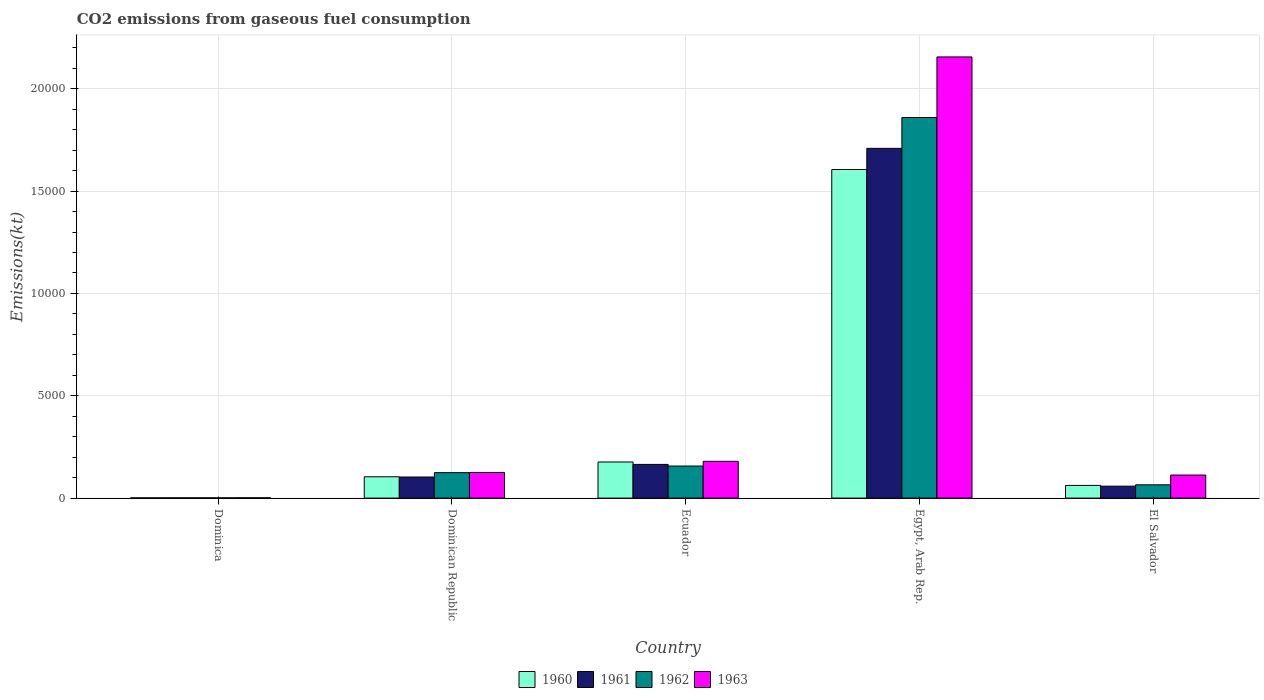How many different coloured bars are there?
Provide a succinct answer. 4. Are the number of bars on each tick of the X-axis equal?
Provide a short and direct response. Yes. How many bars are there on the 2nd tick from the left?
Your answer should be compact. 4. How many bars are there on the 3rd tick from the right?
Provide a succinct answer. 4. What is the label of the 1st group of bars from the left?
Give a very brief answer. Dominica. In how many cases, is the number of bars for a given country not equal to the number of legend labels?
Offer a very short reply. 0. What is the amount of CO2 emitted in 1963 in El Salvador?
Your response must be concise. 1125.77. Across all countries, what is the maximum amount of CO2 emitted in 1961?
Give a very brief answer. 1.71e+04. Across all countries, what is the minimum amount of CO2 emitted in 1960?
Give a very brief answer. 11. In which country was the amount of CO2 emitted in 1960 maximum?
Offer a terse response. Egypt, Arab Rep. In which country was the amount of CO2 emitted in 1960 minimum?
Make the answer very short. Dominica. What is the total amount of CO2 emitted in 1961 in the graph?
Your response must be concise. 2.04e+04. What is the difference between the amount of CO2 emitted in 1963 in Dominican Republic and that in Ecuador?
Make the answer very short. -546.38. What is the difference between the amount of CO2 emitted in 1961 in El Salvador and the amount of CO2 emitted in 1962 in Egypt, Arab Rep.?
Keep it short and to the point. -1.80e+04. What is the average amount of CO2 emitted in 1960 per country?
Your answer should be compact. 3898.02. What is the difference between the amount of CO2 emitted of/in 1961 and amount of CO2 emitted of/in 1963 in Egypt, Arab Rep.?
Your response must be concise. -4466.41. What is the ratio of the amount of CO2 emitted in 1962 in Ecuador to that in El Salvador?
Give a very brief answer. 2.41. Is the difference between the amount of CO2 emitted in 1961 in Ecuador and Egypt, Arab Rep. greater than the difference between the amount of CO2 emitted in 1963 in Ecuador and Egypt, Arab Rep.?
Provide a succinct answer. Yes. What is the difference between the highest and the second highest amount of CO2 emitted in 1963?
Your response must be concise. 1.98e+04. What is the difference between the highest and the lowest amount of CO2 emitted in 1962?
Make the answer very short. 1.86e+04. Is the sum of the amount of CO2 emitted in 1963 in Dominica and Egypt, Arab Rep. greater than the maximum amount of CO2 emitted in 1961 across all countries?
Your response must be concise. Yes. What does the 2nd bar from the left in El Salvador represents?
Keep it short and to the point. 1961. Is it the case that in every country, the sum of the amount of CO2 emitted in 1961 and amount of CO2 emitted in 1962 is greater than the amount of CO2 emitted in 1963?
Your answer should be compact. Yes. How many bars are there?
Your response must be concise. 20. Are all the bars in the graph horizontal?
Provide a short and direct response. No. What is the difference between two consecutive major ticks on the Y-axis?
Your response must be concise. 5000. Are the values on the major ticks of Y-axis written in scientific E-notation?
Give a very brief answer. No. Does the graph contain any zero values?
Provide a succinct answer. No. Does the graph contain grids?
Your answer should be very brief. Yes. How are the legend labels stacked?
Keep it short and to the point. Horizontal. What is the title of the graph?
Provide a short and direct response. CO2 emissions from gaseous fuel consumption. Does "1996" appear as one of the legend labels in the graph?
Your response must be concise. No. What is the label or title of the X-axis?
Keep it short and to the point. Country. What is the label or title of the Y-axis?
Your response must be concise. Emissions(kt). What is the Emissions(kt) in 1960 in Dominica?
Make the answer very short. 11. What is the Emissions(kt) in 1961 in Dominica?
Ensure brevity in your answer.  11. What is the Emissions(kt) of 1962 in Dominica?
Provide a succinct answer. 11. What is the Emissions(kt) in 1963 in Dominica?
Make the answer very short. 14.67. What is the Emissions(kt) of 1960 in Dominican Republic?
Give a very brief answer. 1041.43. What is the Emissions(kt) in 1961 in Dominican Republic?
Give a very brief answer. 1030.43. What is the Emissions(kt) of 1962 in Dominican Republic?
Give a very brief answer. 1243.11. What is the Emissions(kt) in 1963 in Dominican Republic?
Make the answer very short. 1250.45. What is the Emissions(kt) of 1960 in Ecuador?
Your answer should be compact. 1763.83. What is the Emissions(kt) of 1961 in Ecuador?
Provide a succinct answer. 1646.48. What is the Emissions(kt) in 1962 in Ecuador?
Give a very brief answer. 1565.81. What is the Emissions(kt) of 1963 in Ecuador?
Ensure brevity in your answer.  1796.83. What is the Emissions(kt) of 1960 in Egypt, Arab Rep.?
Provide a succinct answer. 1.61e+04. What is the Emissions(kt) in 1961 in Egypt, Arab Rep.?
Keep it short and to the point. 1.71e+04. What is the Emissions(kt) of 1962 in Egypt, Arab Rep.?
Offer a terse response. 1.86e+04. What is the Emissions(kt) of 1963 in Egypt, Arab Rep.?
Your response must be concise. 2.16e+04. What is the Emissions(kt) of 1960 in El Salvador?
Your answer should be very brief. 619.72. What is the Emissions(kt) in 1961 in El Salvador?
Make the answer very short. 583.05. What is the Emissions(kt) of 1962 in El Salvador?
Give a very brief answer. 649.06. What is the Emissions(kt) in 1963 in El Salvador?
Ensure brevity in your answer.  1125.77. Across all countries, what is the maximum Emissions(kt) in 1960?
Keep it short and to the point. 1.61e+04. Across all countries, what is the maximum Emissions(kt) in 1961?
Keep it short and to the point. 1.71e+04. Across all countries, what is the maximum Emissions(kt) in 1962?
Ensure brevity in your answer.  1.86e+04. Across all countries, what is the maximum Emissions(kt) in 1963?
Provide a succinct answer. 2.16e+04. Across all countries, what is the minimum Emissions(kt) of 1960?
Provide a short and direct response. 11. Across all countries, what is the minimum Emissions(kt) of 1961?
Provide a succinct answer. 11. Across all countries, what is the minimum Emissions(kt) in 1962?
Offer a terse response. 11. Across all countries, what is the minimum Emissions(kt) of 1963?
Ensure brevity in your answer.  14.67. What is the total Emissions(kt) of 1960 in the graph?
Offer a terse response. 1.95e+04. What is the total Emissions(kt) in 1961 in the graph?
Your answer should be compact. 2.04e+04. What is the total Emissions(kt) in 1962 in the graph?
Your response must be concise. 2.21e+04. What is the total Emissions(kt) of 1963 in the graph?
Keep it short and to the point. 2.57e+04. What is the difference between the Emissions(kt) of 1960 in Dominica and that in Dominican Republic?
Your answer should be compact. -1030.43. What is the difference between the Emissions(kt) in 1961 in Dominica and that in Dominican Republic?
Offer a terse response. -1019.43. What is the difference between the Emissions(kt) in 1962 in Dominica and that in Dominican Republic?
Provide a short and direct response. -1232.11. What is the difference between the Emissions(kt) in 1963 in Dominica and that in Dominican Republic?
Offer a very short reply. -1235.78. What is the difference between the Emissions(kt) in 1960 in Dominica and that in Ecuador?
Make the answer very short. -1752.83. What is the difference between the Emissions(kt) of 1961 in Dominica and that in Ecuador?
Make the answer very short. -1635.48. What is the difference between the Emissions(kt) in 1962 in Dominica and that in Ecuador?
Offer a terse response. -1554.81. What is the difference between the Emissions(kt) of 1963 in Dominica and that in Ecuador?
Your answer should be compact. -1782.16. What is the difference between the Emissions(kt) of 1960 in Dominica and that in Egypt, Arab Rep.?
Give a very brief answer. -1.60e+04. What is the difference between the Emissions(kt) in 1961 in Dominica and that in Egypt, Arab Rep.?
Provide a succinct answer. -1.71e+04. What is the difference between the Emissions(kt) in 1962 in Dominica and that in Egypt, Arab Rep.?
Your response must be concise. -1.86e+04. What is the difference between the Emissions(kt) of 1963 in Dominica and that in Egypt, Arab Rep.?
Your answer should be compact. -2.15e+04. What is the difference between the Emissions(kt) of 1960 in Dominica and that in El Salvador?
Your answer should be compact. -608.72. What is the difference between the Emissions(kt) in 1961 in Dominica and that in El Salvador?
Your response must be concise. -572.05. What is the difference between the Emissions(kt) in 1962 in Dominica and that in El Salvador?
Keep it short and to the point. -638.06. What is the difference between the Emissions(kt) of 1963 in Dominica and that in El Salvador?
Your answer should be very brief. -1111.1. What is the difference between the Emissions(kt) of 1960 in Dominican Republic and that in Ecuador?
Your answer should be compact. -722.4. What is the difference between the Emissions(kt) in 1961 in Dominican Republic and that in Ecuador?
Give a very brief answer. -616.06. What is the difference between the Emissions(kt) in 1962 in Dominican Republic and that in Ecuador?
Provide a short and direct response. -322.7. What is the difference between the Emissions(kt) of 1963 in Dominican Republic and that in Ecuador?
Offer a terse response. -546.38. What is the difference between the Emissions(kt) in 1960 in Dominican Republic and that in Egypt, Arab Rep.?
Keep it short and to the point. -1.50e+04. What is the difference between the Emissions(kt) in 1961 in Dominican Republic and that in Egypt, Arab Rep.?
Provide a short and direct response. -1.61e+04. What is the difference between the Emissions(kt) of 1962 in Dominican Republic and that in Egypt, Arab Rep.?
Keep it short and to the point. -1.74e+04. What is the difference between the Emissions(kt) of 1963 in Dominican Republic and that in Egypt, Arab Rep.?
Offer a terse response. -2.03e+04. What is the difference between the Emissions(kt) of 1960 in Dominican Republic and that in El Salvador?
Your answer should be very brief. 421.7. What is the difference between the Emissions(kt) of 1961 in Dominican Republic and that in El Salvador?
Offer a terse response. 447.37. What is the difference between the Emissions(kt) in 1962 in Dominican Republic and that in El Salvador?
Offer a very short reply. 594.05. What is the difference between the Emissions(kt) of 1963 in Dominican Republic and that in El Salvador?
Your response must be concise. 124.68. What is the difference between the Emissions(kt) in 1960 in Ecuador and that in Egypt, Arab Rep.?
Your answer should be compact. -1.43e+04. What is the difference between the Emissions(kt) of 1961 in Ecuador and that in Egypt, Arab Rep.?
Make the answer very short. -1.54e+04. What is the difference between the Emissions(kt) of 1962 in Ecuador and that in Egypt, Arab Rep.?
Offer a very short reply. -1.70e+04. What is the difference between the Emissions(kt) of 1963 in Ecuador and that in Egypt, Arab Rep.?
Your answer should be very brief. -1.98e+04. What is the difference between the Emissions(kt) in 1960 in Ecuador and that in El Salvador?
Make the answer very short. 1144.1. What is the difference between the Emissions(kt) of 1961 in Ecuador and that in El Salvador?
Provide a short and direct response. 1063.43. What is the difference between the Emissions(kt) of 1962 in Ecuador and that in El Salvador?
Provide a short and direct response. 916.75. What is the difference between the Emissions(kt) of 1963 in Ecuador and that in El Salvador?
Make the answer very short. 671.06. What is the difference between the Emissions(kt) of 1960 in Egypt, Arab Rep. and that in El Salvador?
Your answer should be very brief. 1.54e+04. What is the difference between the Emissions(kt) in 1961 in Egypt, Arab Rep. and that in El Salvador?
Your answer should be compact. 1.65e+04. What is the difference between the Emissions(kt) in 1962 in Egypt, Arab Rep. and that in El Salvador?
Offer a very short reply. 1.79e+04. What is the difference between the Emissions(kt) in 1963 in Egypt, Arab Rep. and that in El Salvador?
Offer a very short reply. 2.04e+04. What is the difference between the Emissions(kt) in 1960 in Dominica and the Emissions(kt) in 1961 in Dominican Republic?
Ensure brevity in your answer.  -1019.43. What is the difference between the Emissions(kt) of 1960 in Dominica and the Emissions(kt) of 1962 in Dominican Republic?
Provide a succinct answer. -1232.11. What is the difference between the Emissions(kt) in 1960 in Dominica and the Emissions(kt) in 1963 in Dominican Republic?
Make the answer very short. -1239.45. What is the difference between the Emissions(kt) of 1961 in Dominica and the Emissions(kt) of 1962 in Dominican Republic?
Ensure brevity in your answer.  -1232.11. What is the difference between the Emissions(kt) of 1961 in Dominica and the Emissions(kt) of 1963 in Dominican Republic?
Your response must be concise. -1239.45. What is the difference between the Emissions(kt) in 1962 in Dominica and the Emissions(kt) in 1963 in Dominican Republic?
Provide a short and direct response. -1239.45. What is the difference between the Emissions(kt) in 1960 in Dominica and the Emissions(kt) in 1961 in Ecuador?
Your answer should be compact. -1635.48. What is the difference between the Emissions(kt) of 1960 in Dominica and the Emissions(kt) of 1962 in Ecuador?
Your answer should be very brief. -1554.81. What is the difference between the Emissions(kt) in 1960 in Dominica and the Emissions(kt) in 1963 in Ecuador?
Make the answer very short. -1785.83. What is the difference between the Emissions(kt) in 1961 in Dominica and the Emissions(kt) in 1962 in Ecuador?
Provide a succinct answer. -1554.81. What is the difference between the Emissions(kt) in 1961 in Dominica and the Emissions(kt) in 1963 in Ecuador?
Offer a terse response. -1785.83. What is the difference between the Emissions(kt) in 1962 in Dominica and the Emissions(kt) in 1963 in Ecuador?
Your answer should be compact. -1785.83. What is the difference between the Emissions(kt) in 1960 in Dominica and the Emissions(kt) in 1961 in Egypt, Arab Rep.?
Offer a terse response. -1.71e+04. What is the difference between the Emissions(kt) in 1960 in Dominica and the Emissions(kt) in 1962 in Egypt, Arab Rep.?
Your answer should be very brief. -1.86e+04. What is the difference between the Emissions(kt) of 1960 in Dominica and the Emissions(kt) of 1963 in Egypt, Arab Rep.?
Offer a very short reply. -2.15e+04. What is the difference between the Emissions(kt) of 1961 in Dominica and the Emissions(kt) of 1962 in Egypt, Arab Rep.?
Give a very brief answer. -1.86e+04. What is the difference between the Emissions(kt) of 1961 in Dominica and the Emissions(kt) of 1963 in Egypt, Arab Rep.?
Your answer should be compact. -2.15e+04. What is the difference between the Emissions(kt) in 1962 in Dominica and the Emissions(kt) in 1963 in Egypt, Arab Rep.?
Give a very brief answer. -2.15e+04. What is the difference between the Emissions(kt) in 1960 in Dominica and the Emissions(kt) in 1961 in El Salvador?
Your response must be concise. -572.05. What is the difference between the Emissions(kt) in 1960 in Dominica and the Emissions(kt) in 1962 in El Salvador?
Your answer should be compact. -638.06. What is the difference between the Emissions(kt) of 1960 in Dominica and the Emissions(kt) of 1963 in El Salvador?
Give a very brief answer. -1114.77. What is the difference between the Emissions(kt) in 1961 in Dominica and the Emissions(kt) in 1962 in El Salvador?
Keep it short and to the point. -638.06. What is the difference between the Emissions(kt) in 1961 in Dominica and the Emissions(kt) in 1963 in El Salvador?
Your answer should be very brief. -1114.77. What is the difference between the Emissions(kt) of 1962 in Dominica and the Emissions(kt) of 1963 in El Salvador?
Give a very brief answer. -1114.77. What is the difference between the Emissions(kt) of 1960 in Dominican Republic and the Emissions(kt) of 1961 in Ecuador?
Give a very brief answer. -605.05. What is the difference between the Emissions(kt) in 1960 in Dominican Republic and the Emissions(kt) in 1962 in Ecuador?
Your response must be concise. -524.38. What is the difference between the Emissions(kt) of 1960 in Dominican Republic and the Emissions(kt) of 1963 in Ecuador?
Make the answer very short. -755.4. What is the difference between the Emissions(kt) of 1961 in Dominican Republic and the Emissions(kt) of 1962 in Ecuador?
Give a very brief answer. -535.38. What is the difference between the Emissions(kt) of 1961 in Dominican Republic and the Emissions(kt) of 1963 in Ecuador?
Your answer should be very brief. -766.4. What is the difference between the Emissions(kt) in 1962 in Dominican Republic and the Emissions(kt) in 1963 in Ecuador?
Provide a short and direct response. -553.72. What is the difference between the Emissions(kt) of 1960 in Dominican Republic and the Emissions(kt) of 1961 in Egypt, Arab Rep.?
Provide a short and direct response. -1.60e+04. What is the difference between the Emissions(kt) in 1960 in Dominican Republic and the Emissions(kt) in 1962 in Egypt, Arab Rep.?
Give a very brief answer. -1.76e+04. What is the difference between the Emissions(kt) of 1960 in Dominican Republic and the Emissions(kt) of 1963 in Egypt, Arab Rep.?
Offer a terse response. -2.05e+04. What is the difference between the Emissions(kt) of 1961 in Dominican Republic and the Emissions(kt) of 1962 in Egypt, Arab Rep.?
Give a very brief answer. -1.76e+04. What is the difference between the Emissions(kt) in 1961 in Dominican Republic and the Emissions(kt) in 1963 in Egypt, Arab Rep.?
Make the answer very short. -2.05e+04. What is the difference between the Emissions(kt) of 1962 in Dominican Republic and the Emissions(kt) of 1963 in Egypt, Arab Rep.?
Provide a short and direct response. -2.03e+04. What is the difference between the Emissions(kt) of 1960 in Dominican Republic and the Emissions(kt) of 1961 in El Salvador?
Make the answer very short. 458.38. What is the difference between the Emissions(kt) of 1960 in Dominican Republic and the Emissions(kt) of 1962 in El Salvador?
Provide a succinct answer. 392.37. What is the difference between the Emissions(kt) in 1960 in Dominican Republic and the Emissions(kt) in 1963 in El Salvador?
Your response must be concise. -84.34. What is the difference between the Emissions(kt) of 1961 in Dominican Republic and the Emissions(kt) of 1962 in El Salvador?
Provide a short and direct response. 381.37. What is the difference between the Emissions(kt) of 1961 in Dominican Republic and the Emissions(kt) of 1963 in El Salvador?
Your answer should be compact. -95.34. What is the difference between the Emissions(kt) of 1962 in Dominican Republic and the Emissions(kt) of 1963 in El Salvador?
Keep it short and to the point. 117.34. What is the difference between the Emissions(kt) in 1960 in Ecuador and the Emissions(kt) in 1961 in Egypt, Arab Rep.?
Make the answer very short. -1.53e+04. What is the difference between the Emissions(kt) in 1960 in Ecuador and the Emissions(kt) in 1962 in Egypt, Arab Rep.?
Offer a very short reply. -1.68e+04. What is the difference between the Emissions(kt) in 1960 in Ecuador and the Emissions(kt) in 1963 in Egypt, Arab Rep.?
Offer a terse response. -1.98e+04. What is the difference between the Emissions(kt) of 1961 in Ecuador and the Emissions(kt) of 1962 in Egypt, Arab Rep.?
Provide a succinct answer. -1.69e+04. What is the difference between the Emissions(kt) in 1961 in Ecuador and the Emissions(kt) in 1963 in Egypt, Arab Rep.?
Keep it short and to the point. -1.99e+04. What is the difference between the Emissions(kt) of 1962 in Ecuador and the Emissions(kt) of 1963 in Egypt, Arab Rep.?
Your answer should be very brief. -2.00e+04. What is the difference between the Emissions(kt) in 1960 in Ecuador and the Emissions(kt) in 1961 in El Salvador?
Your response must be concise. 1180.77. What is the difference between the Emissions(kt) of 1960 in Ecuador and the Emissions(kt) of 1962 in El Salvador?
Your response must be concise. 1114.77. What is the difference between the Emissions(kt) in 1960 in Ecuador and the Emissions(kt) in 1963 in El Salvador?
Offer a terse response. 638.06. What is the difference between the Emissions(kt) in 1961 in Ecuador and the Emissions(kt) in 1962 in El Salvador?
Offer a very short reply. 997.42. What is the difference between the Emissions(kt) of 1961 in Ecuador and the Emissions(kt) of 1963 in El Salvador?
Provide a succinct answer. 520.71. What is the difference between the Emissions(kt) in 1962 in Ecuador and the Emissions(kt) in 1963 in El Salvador?
Offer a very short reply. 440.04. What is the difference between the Emissions(kt) in 1960 in Egypt, Arab Rep. and the Emissions(kt) in 1961 in El Salvador?
Provide a short and direct response. 1.55e+04. What is the difference between the Emissions(kt) in 1960 in Egypt, Arab Rep. and the Emissions(kt) in 1962 in El Salvador?
Provide a short and direct response. 1.54e+04. What is the difference between the Emissions(kt) in 1960 in Egypt, Arab Rep. and the Emissions(kt) in 1963 in El Salvador?
Provide a succinct answer. 1.49e+04. What is the difference between the Emissions(kt) in 1961 in Egypt, Arab Rep. and the Emissions(kt) in 1962 in El Salvador?
Ensure brevity in your answer.  1.64e+04. What is the difference between the Emissions(kt) of 1961 in Egypt, Arab Rep. and the Emissions(kt) of 1963 in El Salvador?
Make the answer very short. 1.60e+04. What is the difference between the Emissions(kt) of 1962 in Egypt, Arab Rep. and the Emissions(kt) of 1963 in El Salvador?
Keep it short and to the point. 1.75e+04. What is the average Emissions(kt) of 1960 per country?
Keep it short and to the point. 3898.02. What is the average Emissions(kt) of 1961 per country?
Give a very brief answer. 4071.84. What is the average Emissions(kt) of 1962 per country?
Offer a very short reply. 4412.87. What is the average Emissions(kt) in 1963 per country?
Ensure brevity in your answer.  5148.47. What is the difference between the Emissions(kt) in 1960 and Emissions(kt) in 1963 in Dominica?
Keep it short and to the point. -3.67. What is the difference between the Emissions(kt) of 1961 and Emissions(kt) of 1962 in Dominica?
Your response must be concise. 0. What is the difference between the Emissions(kt) of 1961 and Emissions(kt) of 1963 in Dominica?
Offer a very short reply. -3.67. What is the difference between the Emissions(kt) in 1962 and Emissions(kt) in 1963 in Dominica?
Your response must be concise. -3.67. What is the difference between the Emissions(kt) of 1960 and Emissions(kt) of 1961 in Dominican Republic?
Offer a very short reply. 11. What is the difference between the Emissions(kt) in 1960 and Emissions(kt) in 1962 in Dominican Republic?
Keep it short and to the point. -201.69. What is the difference between the Emissions(kt) in 1960 and Emissions(kt) in 1963 in Dominican Republic?
Provide a succinct answer. -209.02. What is the difference between the Emissions(kt) of 1961 and Emissions(kt) of 1962 in Dominican Republic?
Ensure brevity in your answer.  -212.69. What is the difference between the Emissions(kt) in 1961 and Emissions(kt) in 1963 in Dominican Republic?
Offer a very short reply. -220.02. What is the difference between the Emissions(kt) in 1962 and Emissions(kt) in 1963 in Dominican Republic?
Offer a terse response. -7.33. What is the difference between the Emissions(kt) in 1960 and Emissions(kt) in 1961 in Ecuador?
Make the answer very short. 117.34. What is the difference between the Emissions(kt) in 1960 and Emissions(kt) in 1962 in Ecuador?
Keep it short and to the point. 198.02. What is the difference between the Emissions(kt) in 1960 and Emissions(kt) in 1963 in Ecuador?
Make the answer very short. -33. What is the difference between the Emissions(kt) of 1961 and Emissions(kt) of 1962 in Ecuador?
Provide a short and direct response. 80.67. What is the difference between the Emissions(kt) in 1961 and Emissions(kt) in 1963 in Ecuador?
Make the answer very short. -150.35. What is the difference between the Emissions(kt) in 1962 and Emissions(kt) in 1963 in Ecuador?
Give a very brief answer. -231.02. What is the difference between the Emissions(kt) in 1960 and Emissions(kt) in 1961 in Egypt, Arab Rep.?
Provide a succinct answer. -1034.09. What is the difference between the Emissions(kt) in 1960 and Emissions(kt) in 1962 in Egypt, Arab Rep.?
Provide a short and direct response. -2541.23. What is the difference between the Emissions(kt) in 1960 and Emissions(kt) in 1963 in Egypt, Arab Rep.?
Your answer should be very brief. -5500.5. What is the difference between the Emissions(kt) of 1961 and Emissions(kt) of 1962 in Egypt, Arab Rep.?
Offer a terse response. -1507.14. What is the difference between the Emissions(kt) in 1961 and Emissions(kt) in 1963 in Egypt, Arab Rep.?
Your response must be concise. -4466.41. What is the difference between the Emissions(kt) of 1962 and Emissions(kt) of 1963 in Egypt, Arab Rep.?
Provide a short and direct response. -2959.27. What is the difference between the Emissions(kt) in 1960 and Emissions(kt) in 1961 in El Salvador?
Provide a succinct answer. 36.67. What is the difference between the Emissions(kt) of 1960 and Emissions(kt) of 1962 in El Salvador?
Offer a terse response. -29.34. What is the difference between the Emissions(kt) in 1960 and Emissions(kt) in 1963 in El Salvador?
Provide a succinct answer. -506.05. What is the difference between the Emissions(kt) of 1961 and Emissions(kt) of 1962 in El Salvador?
Offer a very short reply. -66.01. What is the difference between the Emissions(kt) in 1961 and Emissions(kt) in 1963 in El Salvador?
Give a very brief answer. -542.72. What is the difference between the Emissions(kt) in 1962 and Emissions(kt) in 1963 in El Salvador?
Make the answer very short. -476.71. What is the ratio of the Emissions(kt) of 1960 in Dominica to that in Dominican Republic?
Your response must be concise. 0.01. What is the ratio of the Emissions(kt) in 1961 in Dominica to that in Dominican Republic?
Offer a terse response. 0.01. What is the ratio of the Emissions(kt) in 1962 in Dominica to that in Dominican Republic?
Offer a terse response. 0.01. What is the ratio of the Emissions(kt) in 1963 in Dominica to that in Dominican Republic?
Provide a succinct answer. 0.01. What is the ratio of the Emissions(kt) in 1960 in Dominica to that in Ecuador?
Your answer should be compact. 0.01. What is the ratio of the Emissions(kt) of 1961 in Dominica to that in Ecuador?
Your answer should be compact. 0.01. What is the ratio of the Emissions(kt) of 1962 in Dominica to that in Ecuador?
Your answer should be compact. 0.01. What is the ratio of the Emissions(kt) in 1963 in Dominica to that in Ecuador?
Provide a succinct answer. 0.01. What is the ratio of the Emissions(kt) of 1960 in Dominica to that in Egypt, Arab Rep.?
Your answer should be very brief. 0. What is the ratio of the Emissions(kt) in 1961 in Dominica to that in Egypt, Arab Rep.?
Make the answer very short. 0. What is the ratio of the Emissions(kt) in 1962 in Dominica to that in Egypt, Arab Rep.?
Your response must be concise. 0. What is the ratio of the Emissions(kt) in 1963 in Dominica to that in Egypt, Arab Rep.?
Offer a terse response. 0. What is the ratio of the Emissions(kt) in 1960 in Dominica to that in El Salvador?
Ensure brevity in your answer.  0.02. What is the ratio of the Emissions(kt) in 1961 in Dominica to that in El Salvador?
Your answer should be compact. 0.02. What is the ratio of the Emissions(kt) in 1962 in Dominica to that in El Salvador?
Give a very brief answer. 0.02. What is the ratio of the Emissions(kt) of 1963 in Dominica to that in El Salvador?
Ensure brevity in your answer.  0.01. What is the ratio of the Emissions(kt) in 1960 in Dominican Republic to that in Ecuador?
Give a very brief answer. 0.59. What is the ratio of the Emissions(kt) in 1961 in Dominican Republic to that in Ecuador?
Keep it short and to the point. 0.63. What is the ratio of the Emissions(kt) of 1962 in Dominican Republic to that in Ecuador?
Ensure brevity in your answer.  0.79. What is the ratio of the Emissions(kt) of 1963 in Dominican Republic to that in Ecuador?
Make the answer very short. 0.7. What is the ratio of the Emissions(kt) of 1960 in Dominican Republic to that in Egypt, Arab Rep.?
Make the answer very short. 0.06. What is the ratio of the Emissions(kt) of 1961 in Dominican Republic to that in Egypt, Arab Rep.?
Your answer should be very brief. 0.06. What is the ratio of the Emissions(kt) of 1962 in Dominican Republic to that in Egypt, Arab Rep.?
Keep it short and to the point. 0.07. What is the ratio of the Emissions(kt) of 1963 in Dominican Republic to that in Egypt, Arab Rep.?
Offer a very short reply. 0.06. What is the ratio of the Emissions(kt) of 1960 in Dominican Republic to that in El Salvador?
Provide a short and direct response. 1.68. What is the ratio of the Emissions(kt) of 1961 in Dominican Republic to that in El Salvador?
Make the answer very short. 1.77. What is the ratio of the Emissions(kt) of 1962 in Dominican Republic to that in El Salvador?
Your answer should be very brief. 1.92. What is the ratio of the Emissions(kt) of 1963 in Dominican Republic to that in El Salvador?
Offer a very short reply. 1.11. What is the ratio of the Emissions(kt) of 1960 in Ecuador to that in Egypt, Arab Rep.?
Offer a very short reply. 0.11. What is the ratio of the Emissions(kt) in 1961 in Ecuador to that in Egypt, Arab Rep.?
Your response must be concise. 0.1. What is the ratio of the Emissions(kt) in 1962 in Ecuador to that in Egypt, Arab Rep.?
Your answer should be very brief. 0.08. What is the ratio of the Emissions(kt) of 1963 in Ecuador to that in Egypt, Arab Rep.?
Your answer should be very brief. 0.08. What is the ratio of the Emissions(kt) in 1960 in Ecuador to that in El Salvador?
Your answer should be very brief. 2.85. What is the ratio of the Emissions(kt) in 1961 in Ecuador to that in El Salvador?
Your answer should be very brief. 2.82. What is the ratio of the Emissions(kt) of 1962 in Ecuador to that in El Salvador?
Your response must be concise. 2.41. What is the ratio of the Emissions(kt) in 1963 in Ecuador to that in El Salvador?
Your answer should be compact. 1.6. What is the ratio of the Emissions(kt) in 1960 in Egypt, Arab Rep. to that in El Salvador?
Your answer should be very brief. 25.91. What is the ratio of the Emissions(kt) in 1961 in Egypt, Arab Rep. to that in El Salvador?
Keep it short and to the point. 29.31. What is the ratio of the Emissions(kt) in 1962 in Egypt, Arab Rep. to that in El Salvador?
Offer a very short reply. 28.65. What is the ratio of the Emissions(kt) in 1963 in Egypt, Arab Rep. to that in El Salvador?
Your response must be concise. 19.15. What is the difference between the highest and the second highest Emissions(kt) of 1960?
Provide a short and direct response. 1.43e+04. What is the difference between the highest and the second highest Emissions(kt) of 1961?
Offer a terse response. 1.54e+04. What is the difference between the highest and the second highest Emissions(kt) in 1962?
Keep it short and to the point. 1.70e+04. What is the difference between the highest and the second highest Emissions(kt) in 1963?
Make the answer very short. 1.98e+04. What is the difference between the highest and the lowest Emissions(kt) of 1960?
Your response must be concise. 1.60e+04. What is the difference between the highest and the lowest Emissions(kt) in 1961?
Provide a succinct answer. 1.71e+04. What is the difference between the highest and the lowest Emissions(kt) of 1962?
Your answer should be compact. 1.86e+04. What is the difference between the highest and the lowest Emissions(kt) of 1963?
Your response must be concise. 2.15e+04. 